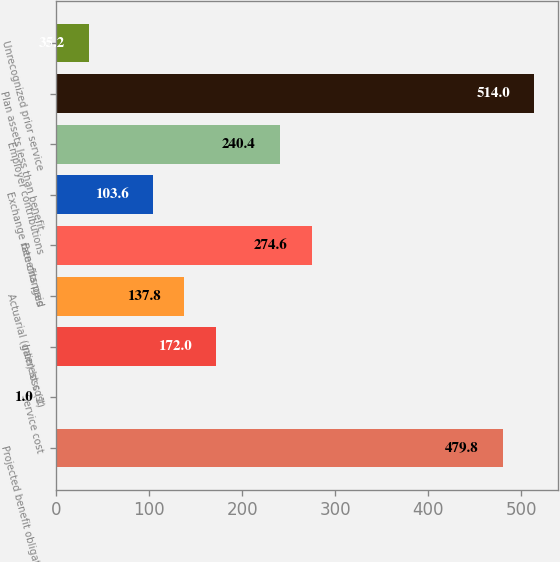<chart> <loc_0><loc_0><loc_500><loc_500><bar_chart><fcel>Projected benefit obligation<fcel>Service cost<fcel>Interest cost<fcel>Actuarial (gain) loss (1)<fcel>Benefits paid<fcel>Exchange rate changes<fcel>Employer contributions<fcel>Plan assets less than benefit<fcel>Unrecognized prior service<nl><fcel>479.8<fcel>1<fcel>172<fcel>137.8<fcel>274.6<fcel>103.6<fcel>240.4<fcel>514<fcel>35.2<nl></chart> 